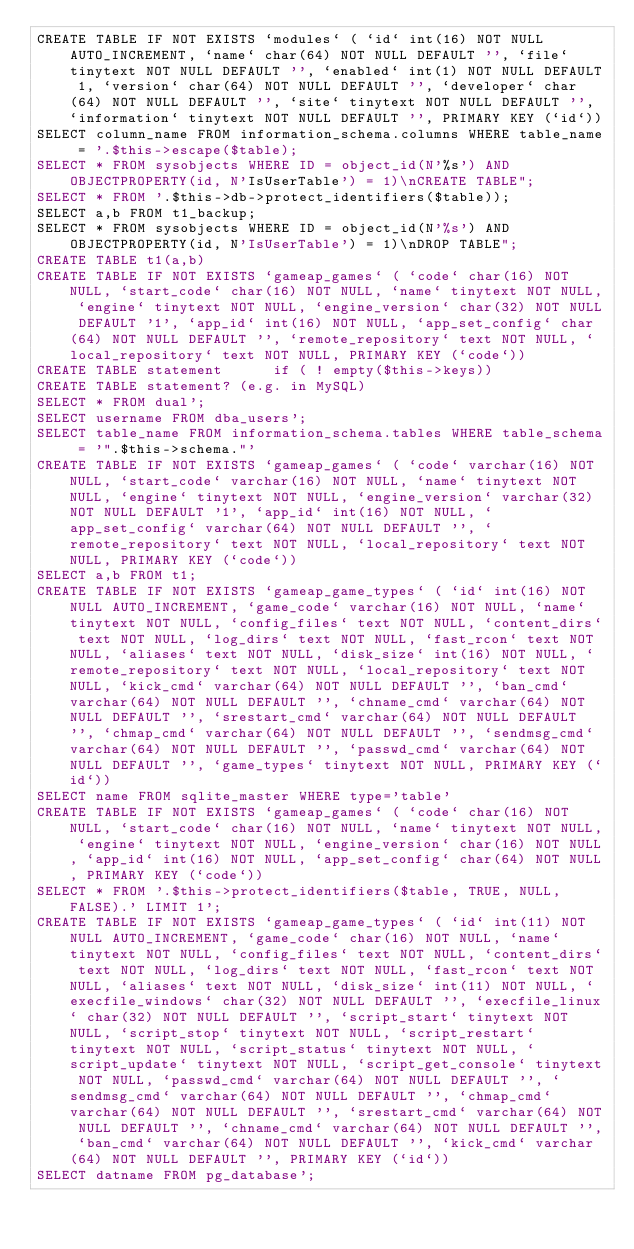Convert code to text. <code><loc_0><loc_0><loc_500><loc_500><_SQL_>CREATE TABLE IF NOT EXISTS `modules` ( `id` int(16) NOT NULL AUTO_INCREMENT, `name` char(64) NOT NULL DEFAULT '', `file` tinytext NOT NULL DEFAULT '', `enabled` int(1) NOT NULL DEFAULT 1, `version` char(64) NOT NULL DEFAULT '', `developer` char(64) NOT NULL DEFAULT '', `site` tinytext NOT NULL DEFAULT '', `information` tinytext NOT NULL DEFAULT '', PRIMARY KEY (`id`))
SELECT column_name FROM information_schema.columns WHERE table_name = '.$this->escape($table);
SELECT * FROM sysobjects WHERE ID = object_id(N'%s') AND OBJECTPROPERTY(id, N'IsUserTable') = 1)\nCREATE TABLE";
SELECT * FROM '.$this->db->protect_identifiers($table));
SELECT a,b FROM t1_backup;
SELECT * FROM sysobjects WHERE ID = object_id(N'%s') AND OBJECTPROPERTY(id, N'IsUserTable') = 1)\nDROP TABLE";
CREATE TABLE t1(a,b)
CREATE TABLE IF NOT EXISTS `gameap_games` ( `code` char(16) NOT NULL, `start_code` char(16) NOT NULL, `name` tinytext NOT NULL, `engine` tinytext NOT NULL, `engine_version` char(32) NOT NULL DEFAULT '1', `app_id` int(16) NOT NULL, `app_set_config` char(64) NOT NULL DEFAULT '', `remote_repository` text NOT NULL, `local_repository` text NOT NULL, PRIMARY KEY (`code`))
CREATE TABLE statement			if ( ! empty($this->keys))
CREATE TABLE statement? (e.g. in MySQL)
SELECT * FROM dual';
SELECT username FROM dba_users';
SELECT table_name FROM information_schema.tables WHERE table_schema = '".$this->schema."'
CREATE TABLE IF NOT EXISTS `gameap_games` ( `code` varchar(16) NOT NULL, `start_code` varchar(16) NOT NULL, `name` tinytext NOT NULL, `engine` tinytext NOT NULL, `engine_version` varchar(32) NOT NULL DEFAULT '1', `app_id` int(16) NOT NULL, `app_set_config` varchar(64) NOT NULL DEFAULT '', `remote_repository` text NOT NULL, `local_repository` text NOT NULL, PRIMARY KEY (`code`))
SELECT a,b FROM t1;
CREATE TABLE IF NOT EXISTS `gameap_game_types` ( `id` int(16) NOT NULL AUTO_INCREMENT, `game_code` varchar(16) NOT NULL, `name` tinytext NOT NULL, `config_files` text NOT NULL, `content_dirs` text NOT NULL, `log_dirs` text NOT NULL, `fast_rcon` text NOT NULL, `aliases` text NOT NULL, `disk_size` int(16) NOT NULL, `remote_repository` text NOT NULL, `local_repository` text NOT NULL, `kick_cmd` varchar(64) NOT NULL DEFAULT '', `ban_cmd` varchar(64) NOT NULL DEFAULT '', `chname_cmd` varchar(64) NOT NULL DEFAULT '', `srestart_cmd` varchar(64) NOT NULL DEFAULT '', `chmap_cmd` varchar(64) NOT NULL DEFAULT '', `sendmsg_cmd` varchar(64) NOT NULL DEFAULT '', `passwd_cmd` varchar(64) NOT NULL DEFAULT '', `game_types` tinytext NOT NULL, PRIMARY KEY (`id`))
SELECT name FROM sqlite_master WHERE type='table'
CREATE TABLE IF NOT EXISTS `gameap_games` ( `code` char(16) NOT NULL, `start_code` char(16) NOT NULL, `name` tinytext NOT NULL, `engine` tinytext NOT NULL, `engine_version` char(16) NOT NULL, `app_id` int(16) NOT NULL, `app_set_config` char(64) NOT NULL, PRIMARY KEY (`code`))
SELECT * FROM '.$this->protect_identifiers($table, TRUE, NULL, FALSE).' LIMIT 1';
CREATE TABLE IF NOT EXISTS `gameap_game_types` ( `id` int(11) NOT NULL AUTO_INCREMENT, `game_code` char(16) NOT NULL, `name` tinytext NOT NULL, `config_files` text NOT NULL, `content_dirs` text NOT NULL, `log_dirs` text NOT NULL, `fast_rcon` text NOT NULL, `aliases` text NOT NULL, `disk_size` int(11) NOT NULL, `execfile_windows` char(32) NOT NULL DEFAULT '', `execfile_linux` char(32) NOT NULL DEFAULT '', `script_start` tinytext NOT NULL, `script_stop` tinytext NOT NULL, `script_restart` tinytext NOT NULL, `script_status` tinytext NOT NULL, `script_update` tinytext NOT NULL, `script_get_console` tinytext NOT NULL, `passwd_cmd` varchar(64) NOT NULL DEFAULT '', `sendmsg_cmd` varchar(64) NOT NULL DEFAULT '', `chmap_cmd` varchar(64) NOT NULL DEFAULT '', `srestart_cmd` varchar(64) NOT NULL DEFAULT '', `chname_cmd` varchar(64) NOT NULL DEFAULT '', `ban_cmd` varchar(64) NOT NULL DEFAULT '', `kick_cmd` varchar(64) NOT NULL DEFAULT '', PRIMARY KEY (`id`))
SELECT datname FROM pg_database';
</code> 